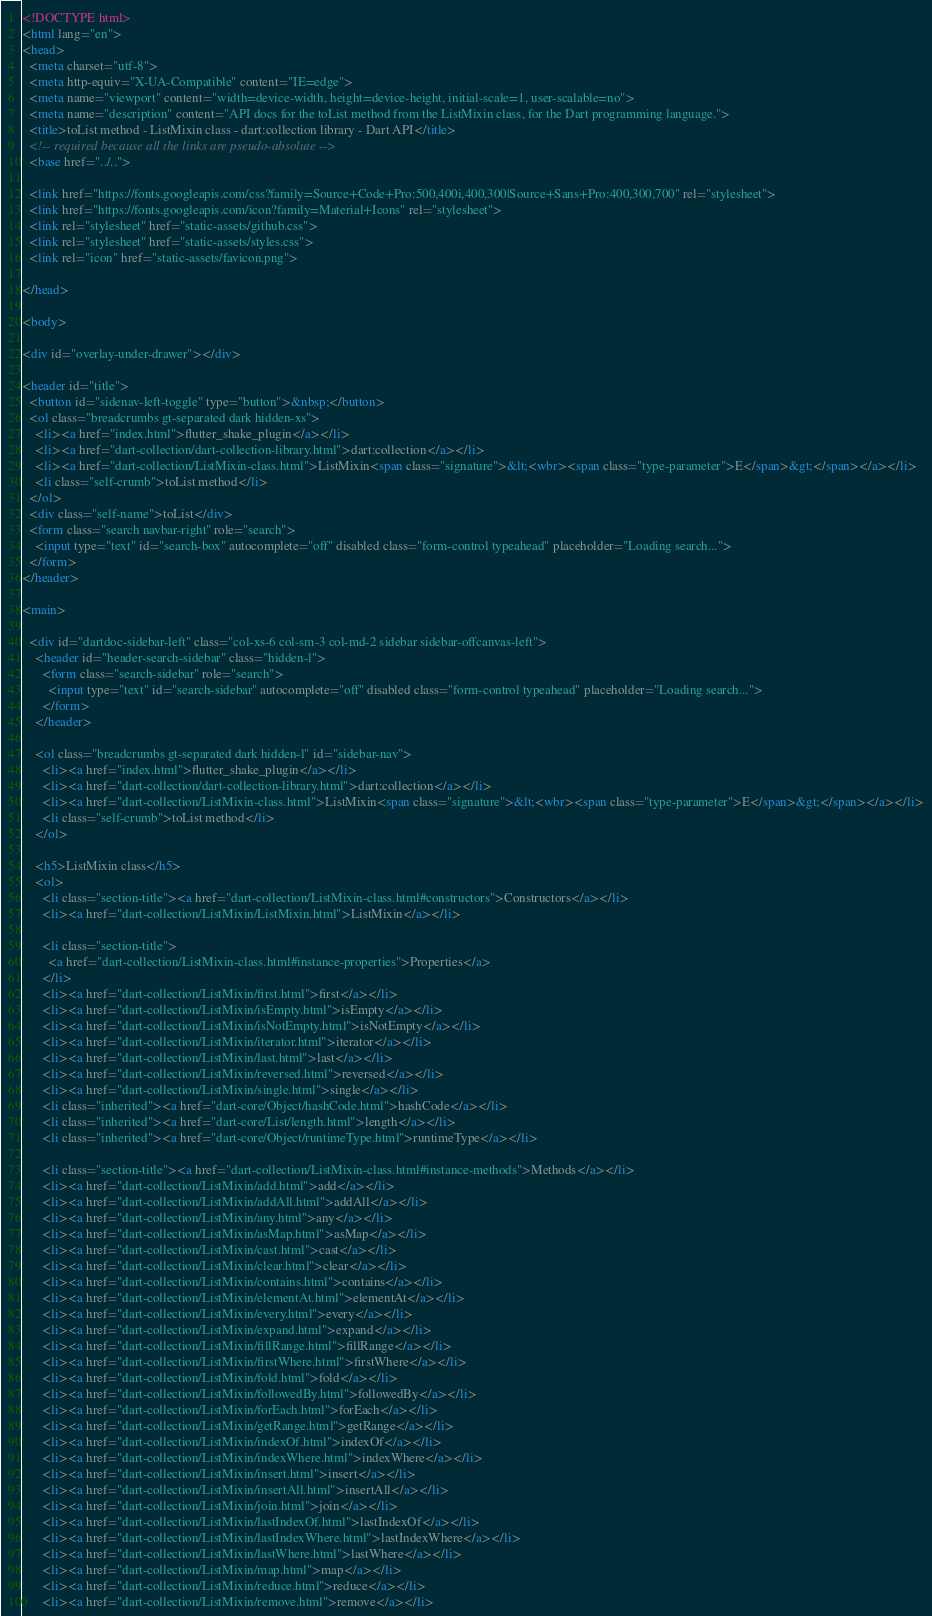Convert code to text. <code><loc_0><loc_0><loc_500><loc_500><_HTML_><!DOCTYPE html>
<html lang="en">
<head>
  <meta charset="utf-8">
  <meta http-equiv="X-UA-Compatible" content="IE=edge">
  <meta name="viewport" content="width=device-width, height=device-height, initial-scale=1, user-scalable=no">
  <meta name="description" content="API docs for the toList method from the ListMixin class, for the Dart programming language.">
  <title>toList method - ListMixin class - dart:collection library - Dart API</title>
  <!-- required because all the links are pseudo-absolute -->
  <base href="../..">

  <link href="https://fonts.googleapis.com/css?family=Source+Code+Pro:500,400i,400,300|Source+Sans+Pro:400,300,700" rel="stylesheet">
  <link href="https://fonts.googleapis.com/icon?family=Material+Icons" rel="stylesheet">
  <link rel="stylesheet" href="static-assets/github.css">
  <link rel="stylesheet" href="static-assets/styles.css">
  <link rel="icon" href="static-assets/favicon.png">
  
</head>

<body>

<div id="overlay-under-drawer"></div>

<header id="title">
  <button id="sidenav-left-toggle" type="button">&nbsp;</button>
  <ol class="breadcrumbs gt-separated dark hidden-xs">
    <li><a href="index.html">flutter_shake_plugin</a></li>
    <li><a href="dart-collection/dart-collection-library.html">dart:collection</a></li>
    <li><a href="dart-collection/ListMixin-class.html">ListMixin<span class="signature">&lt;<wbr><span class="type-parameter">E</span>&gt;</span></a></li>
    <li class="self-crumb">toList method</li>
  </ol>
  <div class="self-name">toList</div>
  <form class="search navbar-right" role="search">
    <input type="text" id="search-box" autocomplete="off" disabled class="form-control typeahead" placeholder="Loading search...">
  </form>
</header>

<main>

  <div id="dartdoc-sidebar-left" class="col-xs-6 col-sm-3 col-md-2 sidebar sidebar-offcanvas-left">
    <header id="header-search-sidebar" class="hidden-l">
      <form class="search-sidebar" role="search">
        <input type="text" id="search-sidebar" autocomplete="off" disabled class="form-control typeahead" placeholder="Loading search...">
      </form>
    </header>
    
    <ol class="breadcrumbs gt-separated dark hidden-l" id="sidebar-nav">
      <li><a href="index.html">flutter_shake_plugin</a></li>
      <li><a href="dart-collection/dart-collection-library.html">dart:collection</a></li>
      <li><a href="dart-collection/ListMixin-class.html">ListMixin<span class="signature">&lt;<wbr><span class="type-parameter">E</span>&gt;</span></a></li>
      <li class="self-crumb">toList method</li>
    </ol>
    
    <h5>ListMixin class</h5>
    <ol>
      <li class="section-title"><a href="dart-collection/ListMixin-class.html#constructors">Constructors</a></li>
      <li><a href="dart-collection/ListMixin/ListMixin.html">ListMixin</a></li>
    
      <li class="section-title">
        <a href="dart-collection/ListMixin-class.html#instance-properties">Properties</a>
      </li>
      <li><a href="dart-collection/ListMixin/first.html">first</a></li>
      <li><a href="dart-collection/ListMixin/isEmpty.html">isEmpty</a></li>
      <li><a href="dart-collection/ListMixin/isNotEmpty.html">isNotEmpty</a></li>
      <li><a href="dart-collection/ListMixin/iterator.html">iterator</a></li>
      <li><a href="dart-collection/ListMixin/last.html">last</a></li>
      <li><a href="dart-collection/ListMixin/reversed.html">reversed</a></li>
      <li><a href="dart-collection/ListMixin/single.html">single</a></li>
      <li class="inherited"><a href="dart-core/Object/hashCode.html">hashCode</a></li>
      <li class="inherited"><a href="dart-core/List/length.html">length</a></li>
      <li class="inherited"><a href="dart-core/Object/runtimeType.html">runtimeType</a></li>
    
      <li class="section-title"><a href="dart-collection/ListMixin-class.html#instance-methods">Methods</a></li>
      <li><a href="dart-collection/ListMixin/add.html">add</a></li>
      <li><a href="dart-collection/ListMixin/addAll.html">addAll</a></li>
      <li><a href="dart-collection/ListMixin/any.html">any</a></li>
      <li><a href="dart-collection/ListMixin/asMap.html">asMap</a></li>
      <li><a href="dart-collection/ListMixin/cast.html">cast</a></li>
      <li><a href="dart-collection/ListMixin/clear.html">clear</a></li>
      <li><a href="dart-collection/ListMixin/contains.html">contains</a></li>
      <li><a href="dart-collection/ListMixin/elementAt.html">elementAt</a></li>
      <li><a href="dart-collection/ListMixin/every.html">every</a></li>
      <li><a href="dart-collection/ListMixin/expand.html">expand</a></li>
      <li><a href="dart-collection/ListMixin/fillRange.html">fillRange</a></li>
      <li><a href="dart-collection/ListMixin/firstWhere.html">firstWhere</a></li>
      <li><a href="dart-collection/ListMixin/fold.html">fold</a></li>
      <li><a href="dart-collection/ListMixin/followedBy.html">followedBy</a></li>
      <li><a href="dart-collection/ListMixin/forEach.html">forEach</a></li>
      <li><a href="dart-collection/ListMixin/getRange.html">getRange</a></li>
      <li><a href="dart-collection/ListMixin/indexOf.html">indexOf</a></li>
      <li><a href="dart-collection/ListMixin/indexWhere.html">indexWhere</a></li>
      <li><a href="dart-collection/ListMixin/insert.html">insert</a></li>
      <li><a href="dart-collection/ListMixin/insertAll.html">insertAll</a></li>
      <li><a href="dart-collection/ListMixin/join.html">join</a></li>
      <li><a href="dart-collection/ListMixin/lastIndexOf.html">lastIndexOf</a></li>
      <li><a href="dart-collection/ListMixin/lastIndexWhere.html">lastIndexWhere</a></li>
      <li><a href="dart-collection/ListMixin/lastWhere.html">lastWhere</a></li>
      <li><a href="dart-collection/ListMixin/map.html">map</a></li>
      <li><a href="dart-collection/ListMixin/reduce.html">reduce</a></li>
      <li><a href="dart-collection/ListMixin/remove.html">remove</a></li></code> 